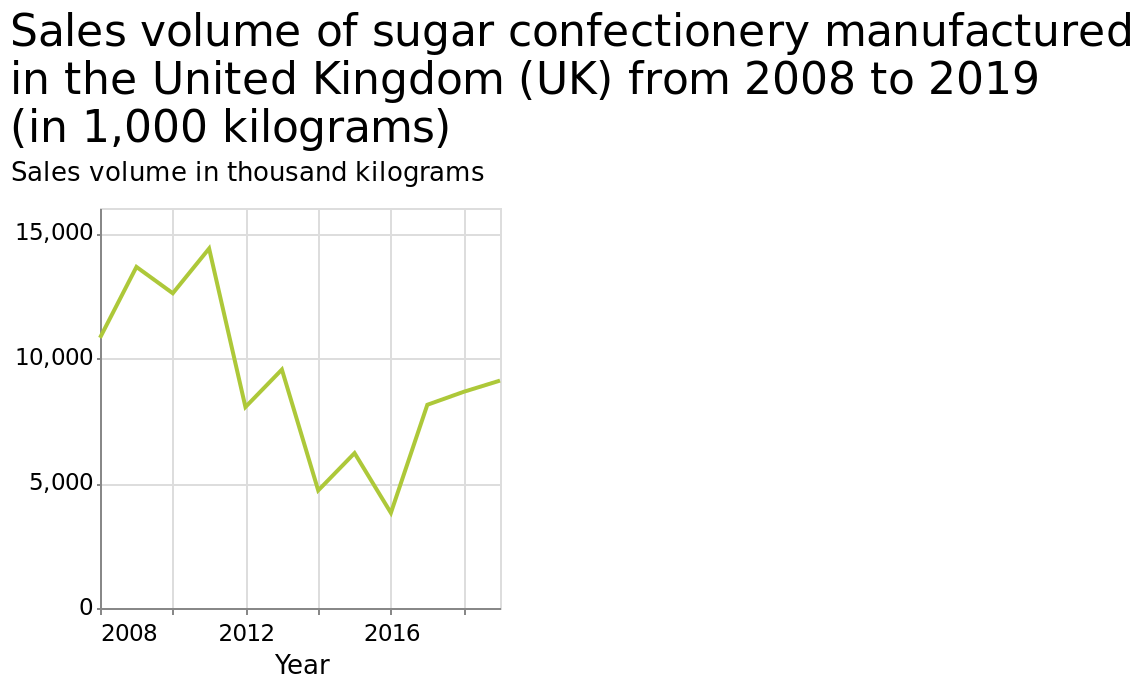<image>
What is the highest sales volume of sugar confectionery recorded in the United Kingdom from 2008 to 2019? The highest sales volume of sugar confectionery recorded in the United Kingdom from 2008 to 2019 is 15,000 thousand kilograms. What was the difference between the highest and lowest sugar volumes in the UK? The difference between the highest and lowest sugar volumes in the UK was 10000. 